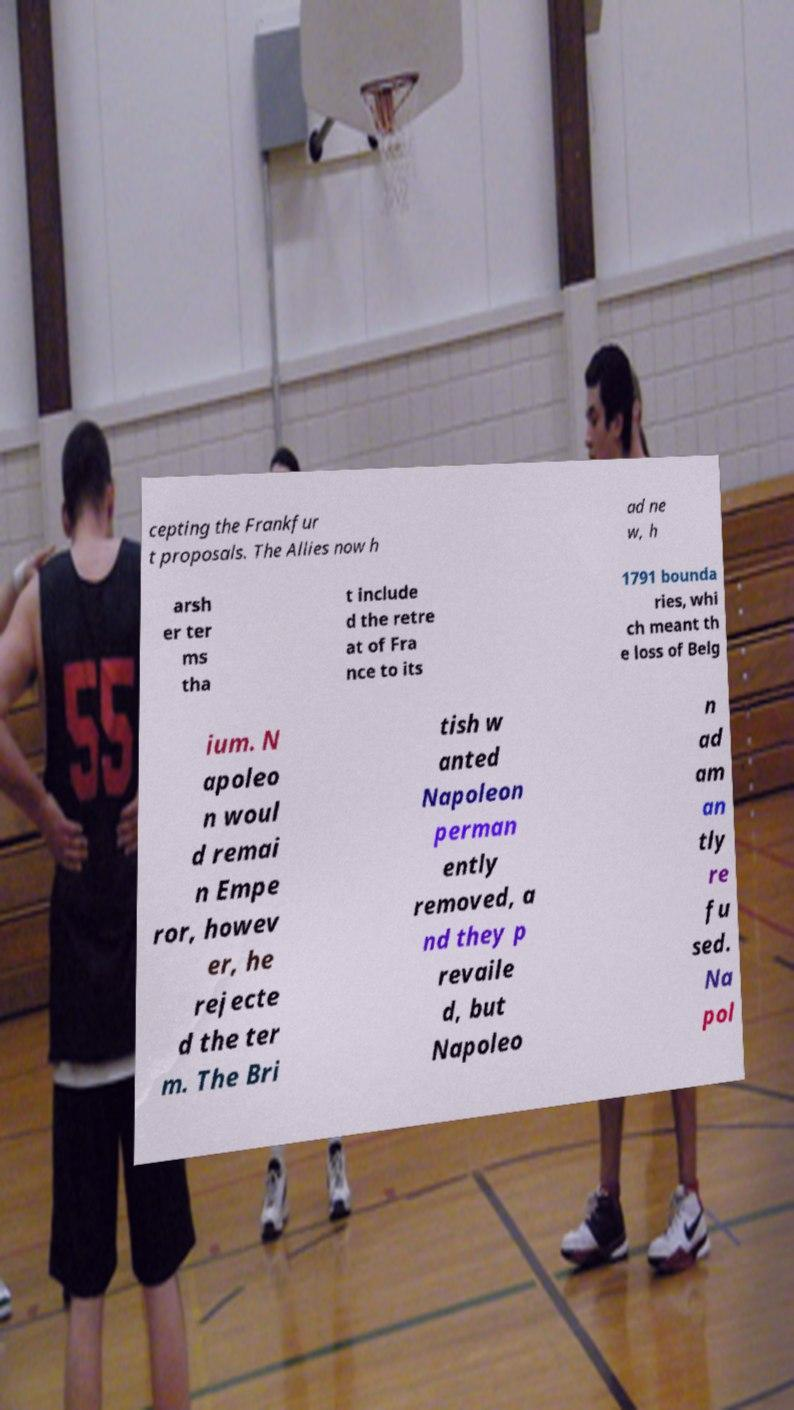What messages or text are displayed in this image? I need them in a readable, typed format. cepting the Frankfur t proposals. The Allies now h ad ne w, h arsh er ter ms tha t include d the retre at of Fra nce to its 1791 bounda ries, whi ch meant th e loss of Belg ium. N apoleo n woul d remai n Empe ror, howev er, he rejecte d the ter m. The Bri tish w anted Napoleon perman ently removed, a nd they p revaile d, but Napoleo n ad am an tly re fu sed. Na pol 